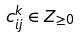Convert formula to latex. <formula><loc_0><loc_0><loc_500><loc_500>c _ { i j } ^ { k } \in Z _ { \geq 0 }</formula> 